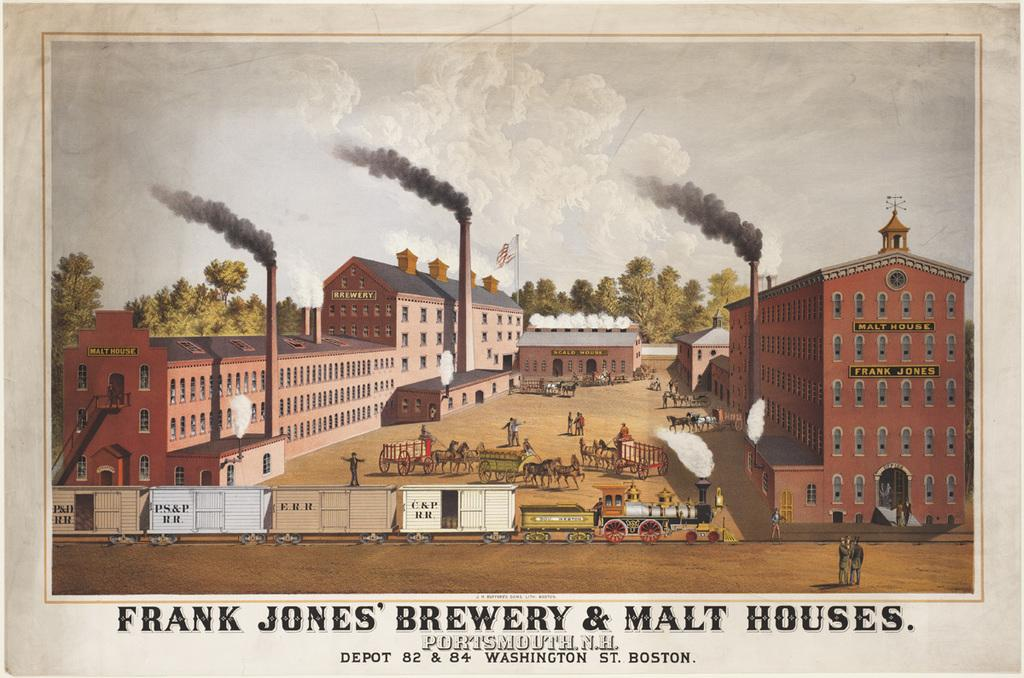Provide a one-sentence caption for the provided image. The old buildings of Frank Jones' brewery and Malt houses. 